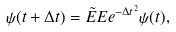<formula> <loc_0><loc_0><loc_500><loc_500>\psi ( t + \Delta t ) = \tilde { E } E e ^ { - \Delta t ^ { 2 } } \psi ( t ) ,</formula> 